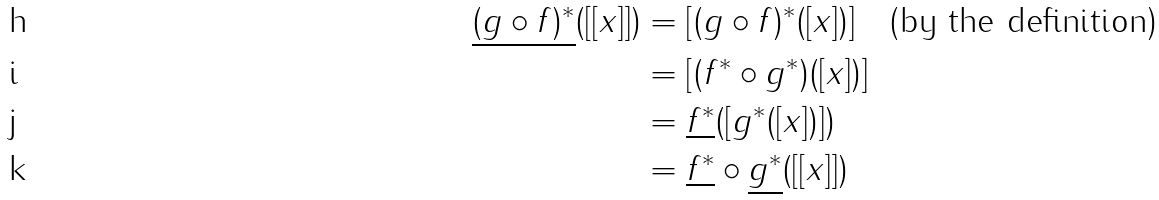Convert formula to latex. <formula><loc_0><loc_0><loc_500><loc_500>\underline { ( g \circ f ) ^ { * } } ( [ [ x ] ] ) & = [ ( g \circ f ) ^ { * } ( [ x ] ) ] \quad \text {(by the definition)} \\ & = [ ( f ^ { * } \circ g ^ { * } ) ( [ x ] ) ] \\ & = \underline { f ^ { * } } ( [ g ^ { * } ( [ x ] ) ] ) \\ & = \underline { f ^ { * } } \circ \underline { g ^ { * } } ( [ [ x ] ] )</formula> 